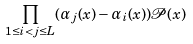Convert formula to latex. <formula><loc_0><loc_0><loc_500><loc_500>\prod _ { 1 \leq i < j \leq L } ( \alpha _ { j } ( x ) - \alpha _ { i } ( x ) ) \mathcal { P } ( x )</formula> 